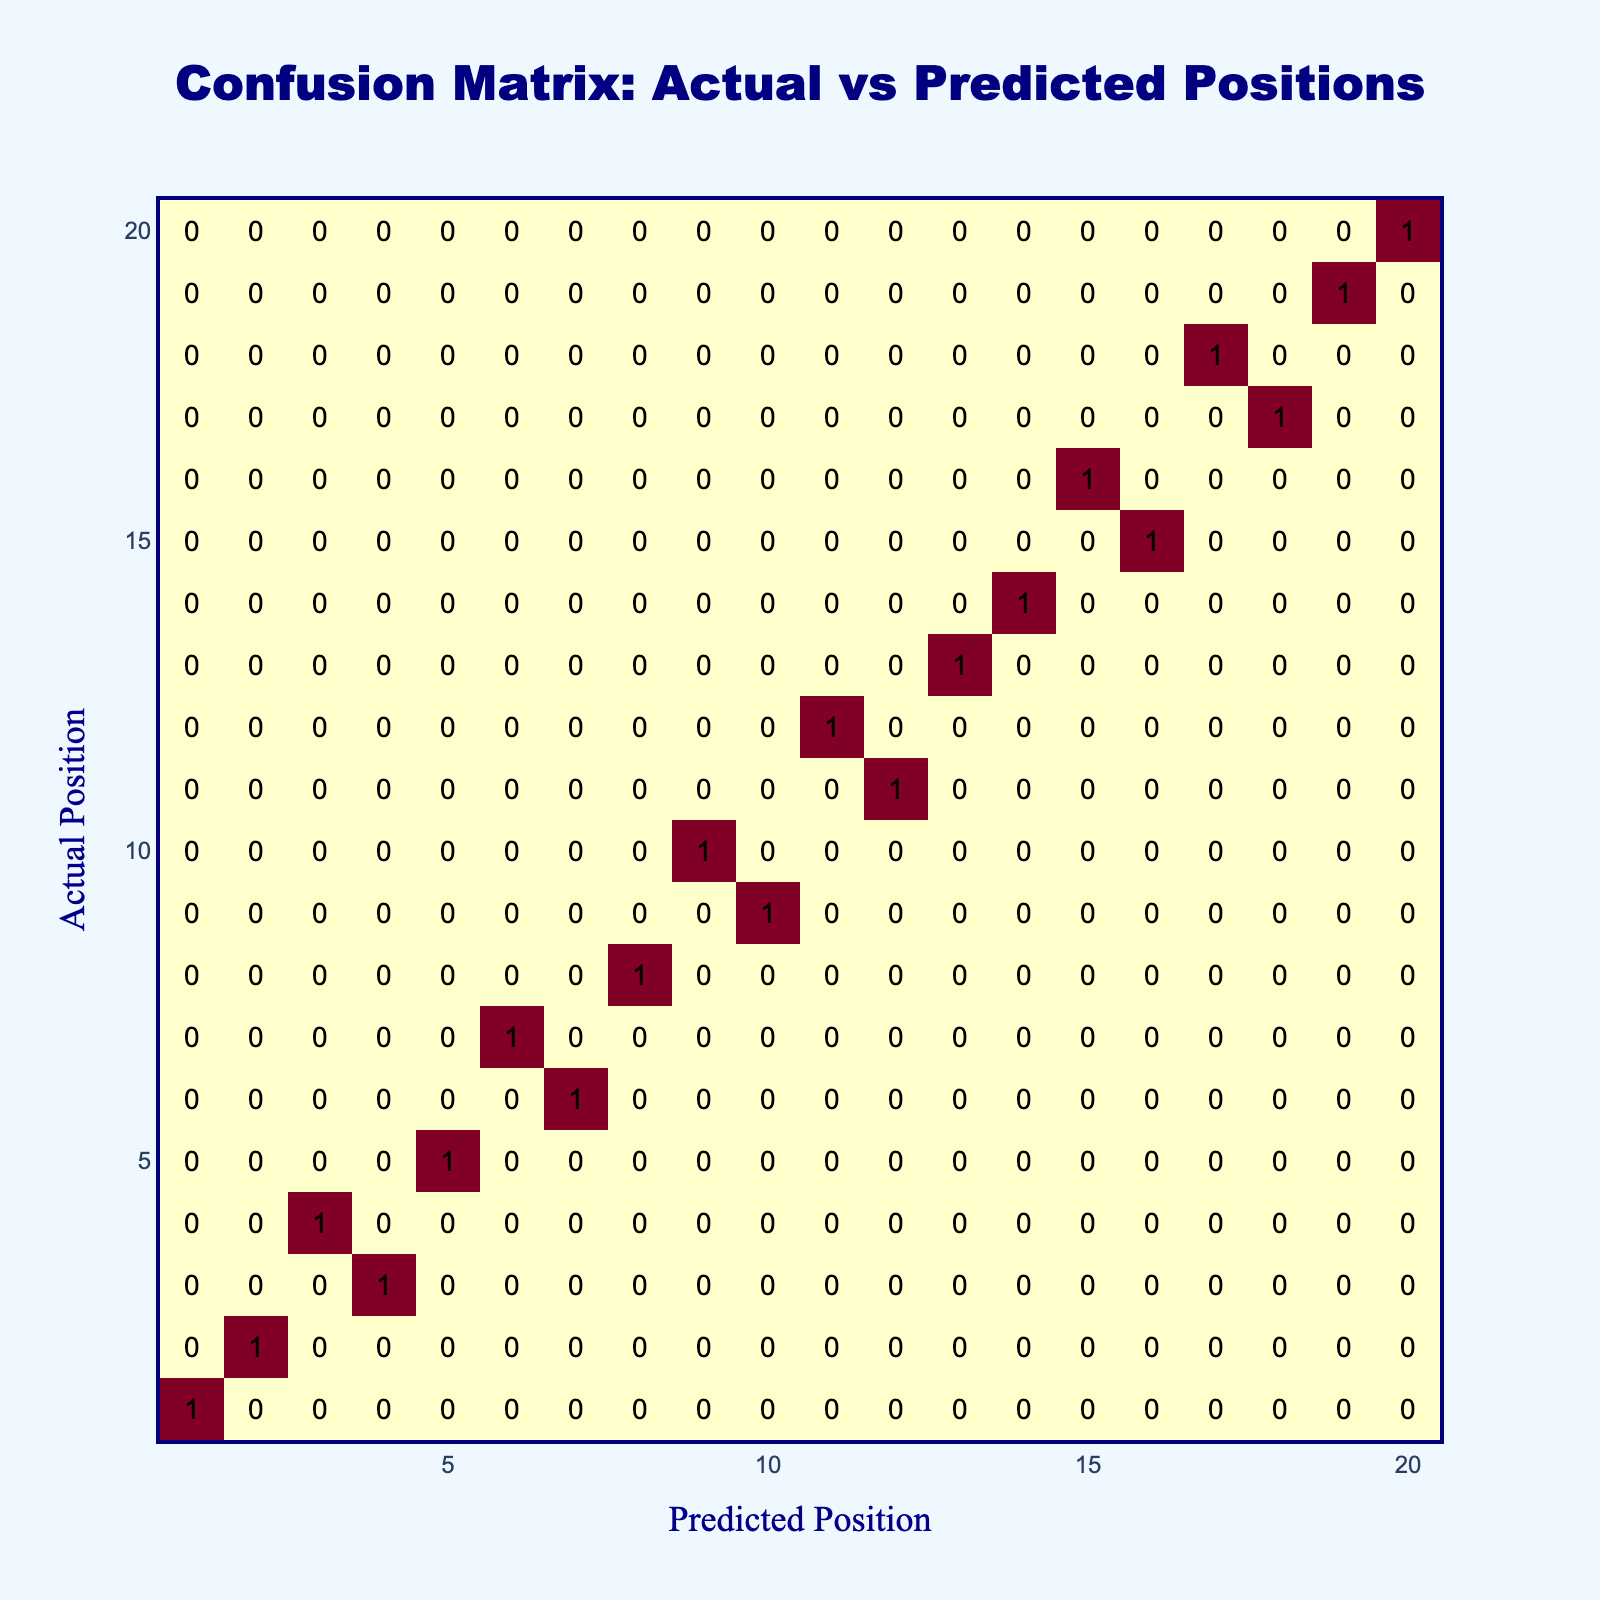What is the predicted position for the actual position of 6? Looking at the table, we find the row corresponding to the actual position of 6. The predicted position in that row is 7.
Answer: 7 How many times did Arnaud Boissières finish in the same position as predicted? We can see the entries where the actual position matches the predicted position, which are the diagonal elements in the table: 1-1, 2-2, 5-5, 8-8, 13-13, 14-14, 19-19, 20-20. There are 8 such entries.
Answer: 8 Is Arnaud Boissières' actual finishing position of 3 matched by the prediction? Looking at the table, for actual position 3, the predicted position is 4. Since these do not match, the answer is false.
Answer: No What is the total number of discrepancies between actual and predicted positions? We can find discrepancies by counting the values off the diagonal in the table where actual does not equal predicted. The discrepancies are: (3,4), (4,3), (6,7), (7,6), (9,10), (10,9), (11,12), (12,11), (15,16), (16,15), and (17,18), (18,17), which gives us 12 discrepancies.
Answer: 12 What is the predicted position for the last actual position of 20? Checking the table’s last row for actual position 20, the predicted position is 20.
Answer: 20 What is the average predicted position when the actual position is 10 or lower? We need to consider only the actual positions from 1 to 10: the predicted positions are 1, 2, 4, 3, 5, 7, 6, 8, 10, 9. The average is calculated as (1 + 2 + 4 + 3 + 5 + 7 + 6 + 8 + 10 + 9) / 10 = 55 / 10 = 5.5.
Answer: 5.5 